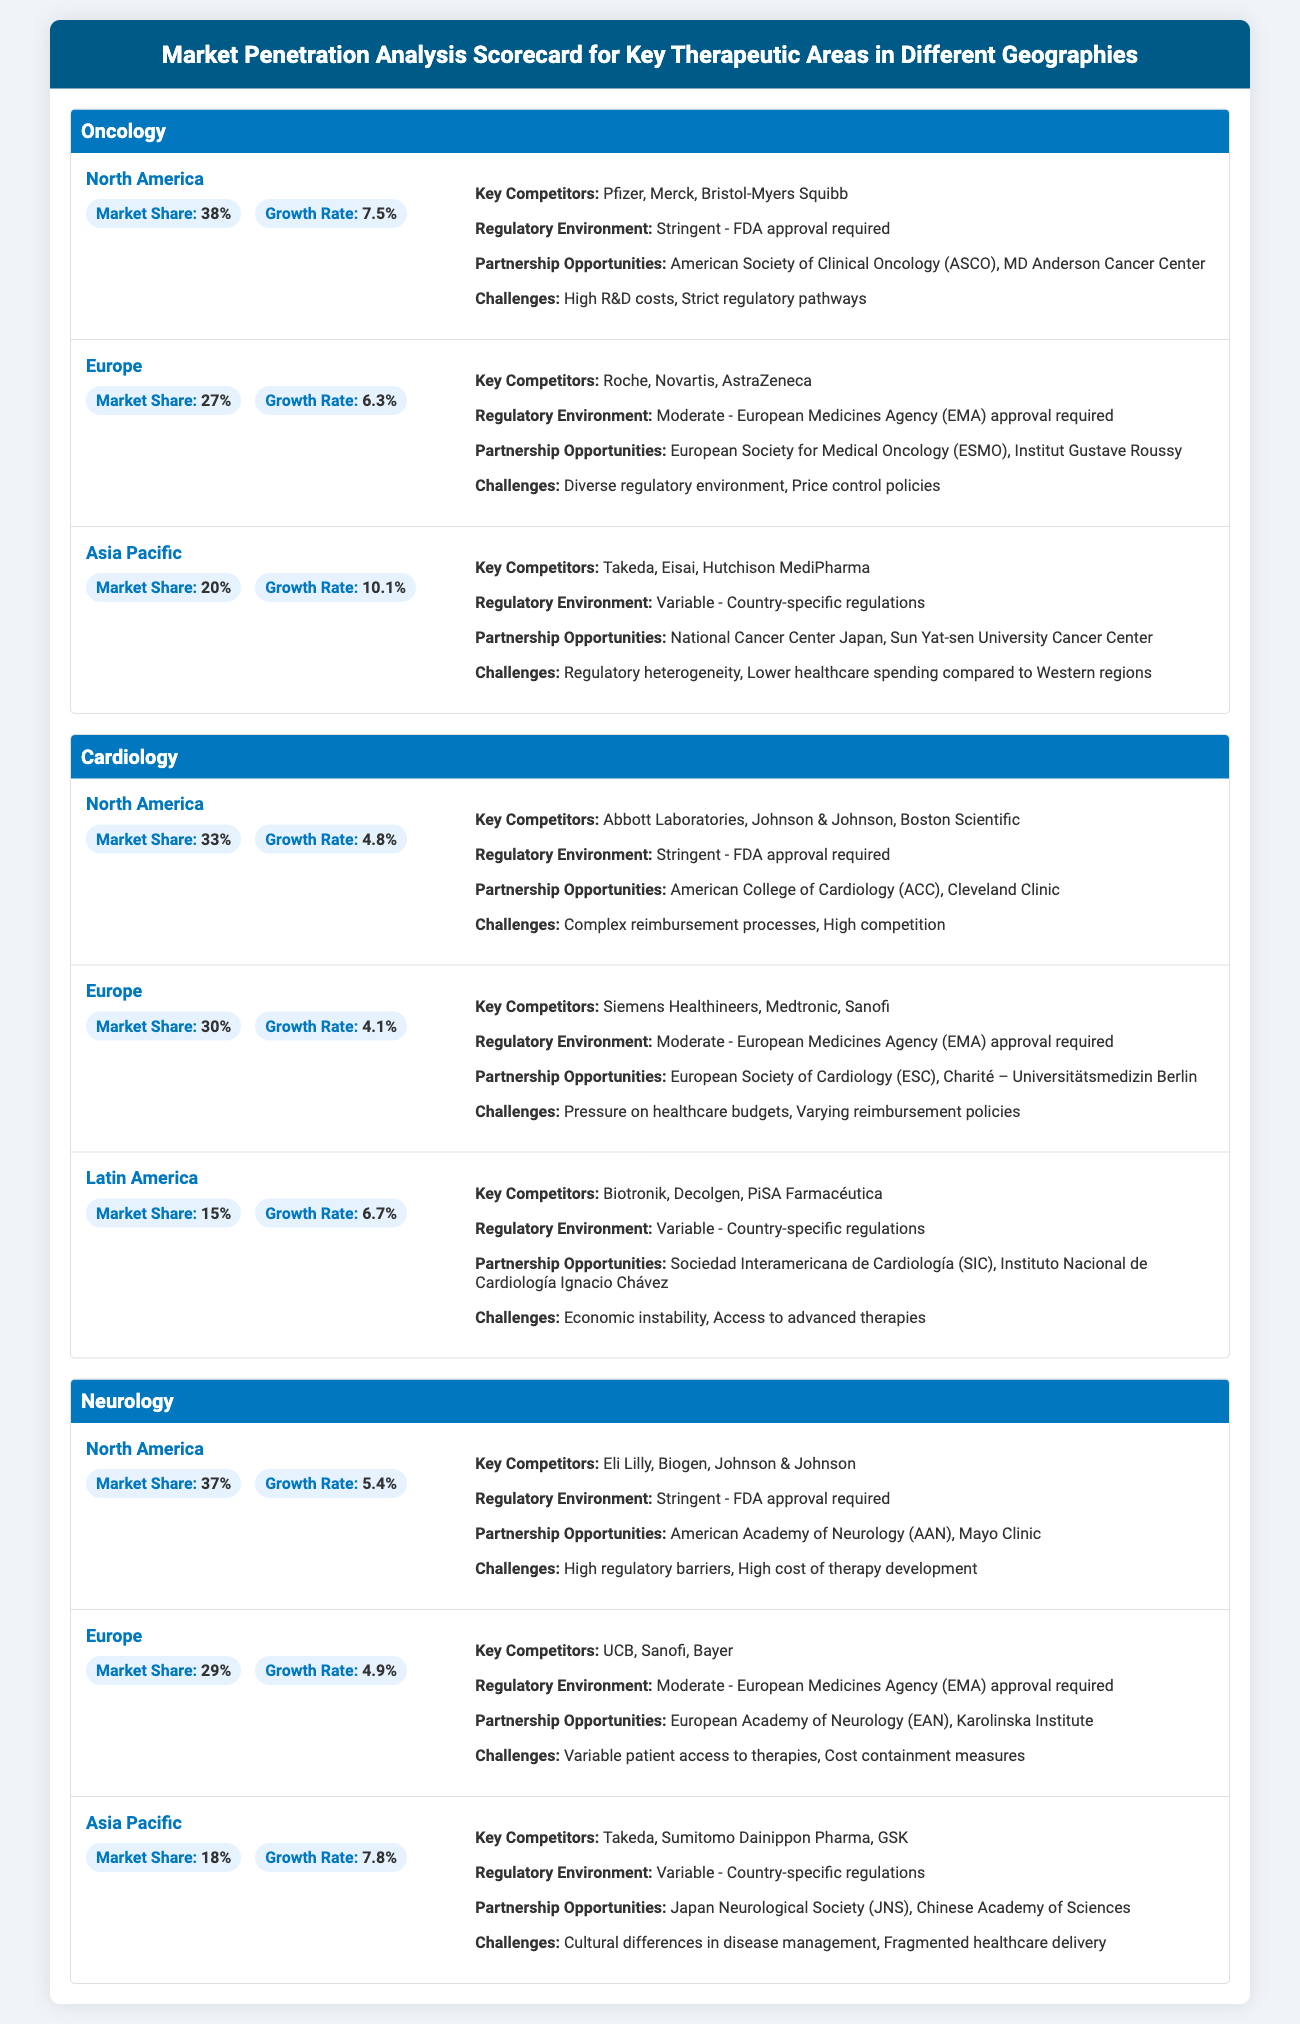what is the market share for Oncology in North America? The market share for Oncology in North America is stated in the document.
Answer: 38% who are the key competitors for Cardiology in Europe? The document lists the key competitors under the Cardiology section for Europe.
Answer: Siemens Healthineers, Medtronic, Sanofi what is the growth rate for Neurology in Asia Pacific? The growth rate for Neurology in Asia Pacific can be found in the specific geography details.
Answer: 7.8% which organization represents a partnership opportunity in North America for Oncology? The document mentions potential partnership opportunities for Oncology in North America.
Answer: American Society of Clinical Oncology (ASCO) what is the regulatory environment for Cardiology in Latin America? The document describes the regulatory environment for Cardiology in Latin America.
Answer: Variable - Country-specific regulations what is the market share for Europe in the Neurology therapeutic area? The document provides the market share for the Neurology therapeutic area in Europe.
Answer: 29% which geographic region has the highest growth rate for Oncology? The growth rates for the oncology regions are compared, revealing the highest one.
Answer: Asia Pacific what challenge is listed for Cardiovascular in North America? The document states key challenges for Cardiology in North America.
Answer: Complex reimbursement processes who are the key competitors in the Oncology therapeutic area in Asia Pacific? The document specifies the key competitors for Oncology in Asia Pacific.
Answer: Takeda, Eisai, Hutchison MediPharma 